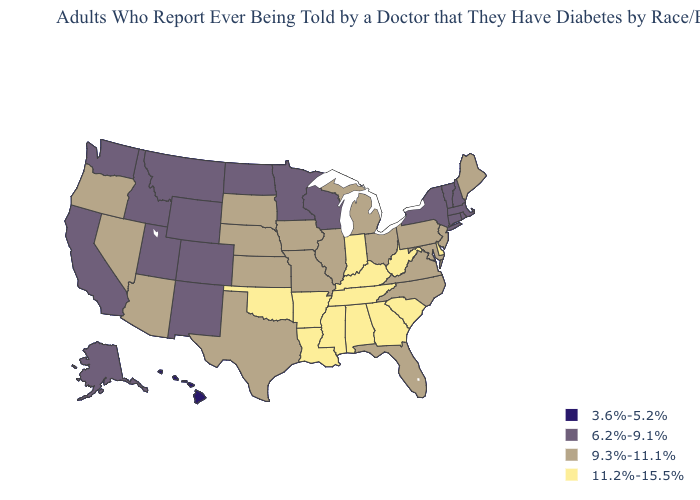What is the value of Florida?
Keep it brief. 9.3%-11.1%. Name the states that have a value in the range 3.6%-5.2%?
Write a very short answer. Hawaii. Does Kentucky have a lower value than Vermont?
Write a very short answer. No. What is the value of Florida?
Be succinct. 9.3%-11.1%. What is the value of Maine?
Give a very brief answer. 9.3%-11.1%. Name the states that have a value in the range 9.3%-11.1%?
Be succinct. Arizona, Florida, Illinois, Iowa, Kansas, Maine, Maryland, Michigan, Missouri, Nebraska, Nevada, New Jersey, North Carolina, Ohio, Oregon, Pennsylvania, South Dakota, Texas, Virginia. Does North Dakota have a lower value than West Virginia?
Give a very brief answer. Yes. What is the value of New Hampshire?
Quick response, please. 6.2%-9.1%. What is the value of Colorado?
Keep it brief. 6.2%-9.1%. Does Maine have the lowest value in the Northeast?
Quick response, please. No. What is the highest value in the South ?
Quick response, please. 11.2%-15.5%. Name the states that have a value in the range 9.3%-11.1%?
Concise answer only. Arizona, Florida, Illinois, Iowa, Kansas, Maine, Maryland, Michigan, Missouri, Nebraska, Nevada, New Jersey, North Carolina, Ohio, Oregon, Pennsylvania, South Dakota, Texas, Virginia. Which states hav the highest value in the MidWest?
Give a very brief answer. Indiana. What is the highest value in the West ?
Quick response, please. 9.3%-11.1%. Which states hav the highest value in the MidWest?
Quick response, please. Indiana. 